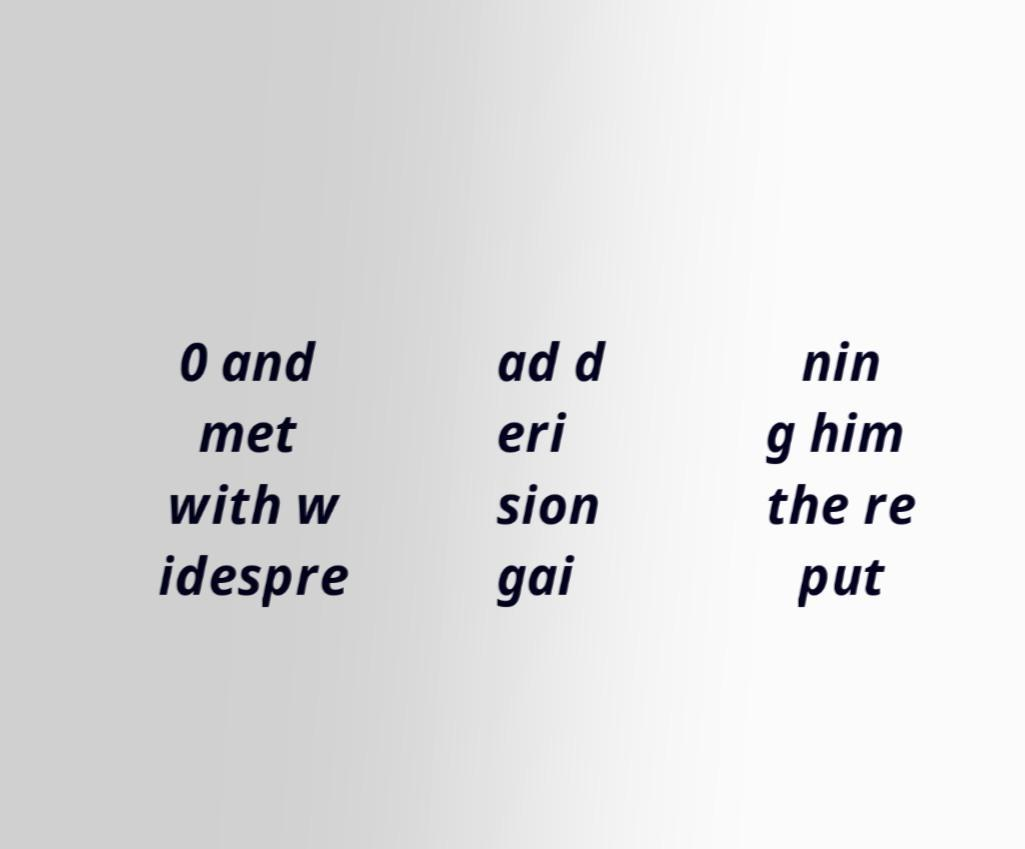For documentation purposes, I need the text within this image transcribed. Could you provide that? 0 and met with w idespre ad d eri sion gai nin g him the re put 